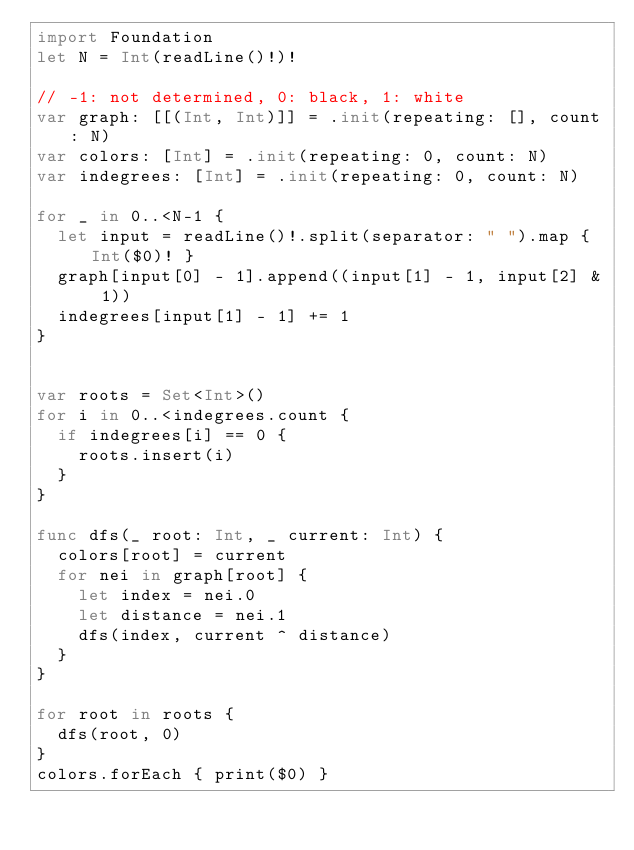Convert code to text. <code><loc_0><loc_0><loc_500><loc_500><_Swift_>import Foundation
let N = Int(readLine()!)!

// -1: not determined, 0: black, 1: white
var graph: [[(Int, Int)]] = .init(repeating: [], count: N)
var colors: [Int] = .init(repeating: 0, count: N)
var indegrees: [Int] = .init(repeating: 0, count: N)

for _ in 0..<N-1 {
  let input = readLine()!.split(separator: " ").map { Int($0)! }
  graph[input[0] - 1].append((input[1] - 1, input[2] & 1))
  indegrees[input[1] - 1] += 1
}


var roots = Set<Int>()
for i in 0..<indegrees.count {
  if indegrees[i] == 0 {
    roots.insert(i)
  }
}

func dfs(_ root: Int, _ current: Int) {
  colors[root] = current
  for nei in graph[root] {
    let index = nei.0
    let distance = nei.1
    dfs(index, current ^ distance)
  }
}

for root in roots {
  dfs(root, 0)
}
colors.forEach { print($0) }
</code> 